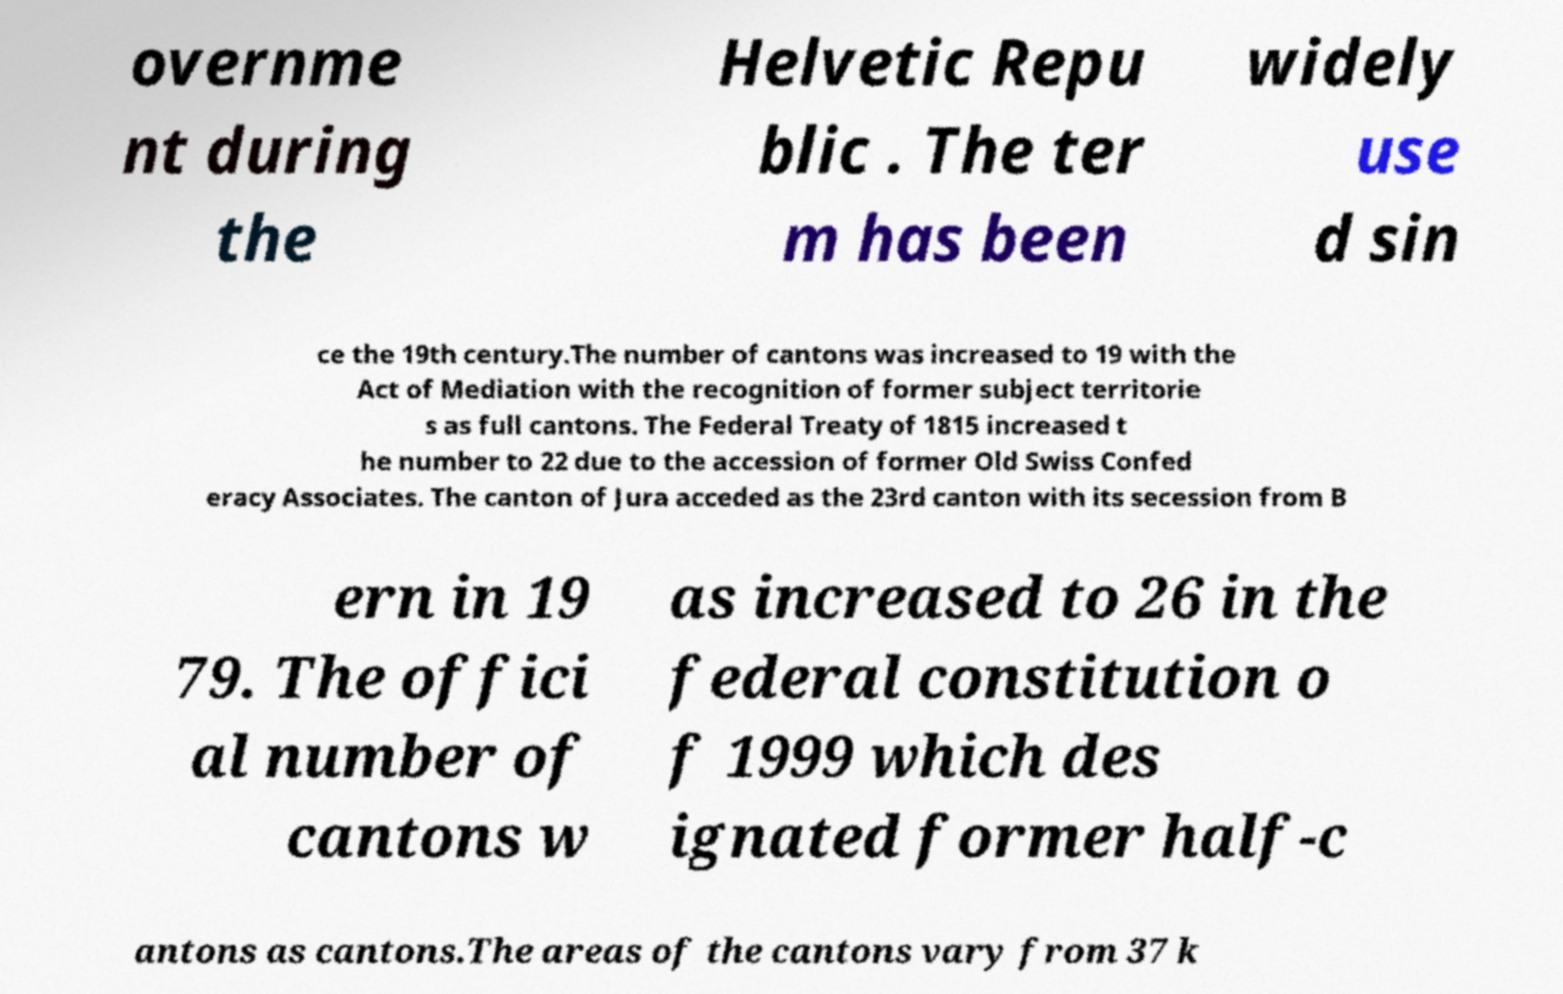Can you accurately transcribe the text from the provided image for me? overnme nt during the Helvetic Repu blic . The ter m has been widely use d sin ce the 19th century.The number of cantons was increased to 19 with the Act of Mediation with the recognition of former subject territorie s as full cantons. The Federal Treaty of 1815 increased t he number to 22 due to the accession of former Old Swiss Confed eracy Associates. The canton of Jura acceded as the 23rd canton with its secession from B ern in 19 79. The offici al number of cantons w as increased to 26 in the federal constitution o f 1999 which des ignated former half-c antons as cantons.The areas of the cantons vary from 37 k 